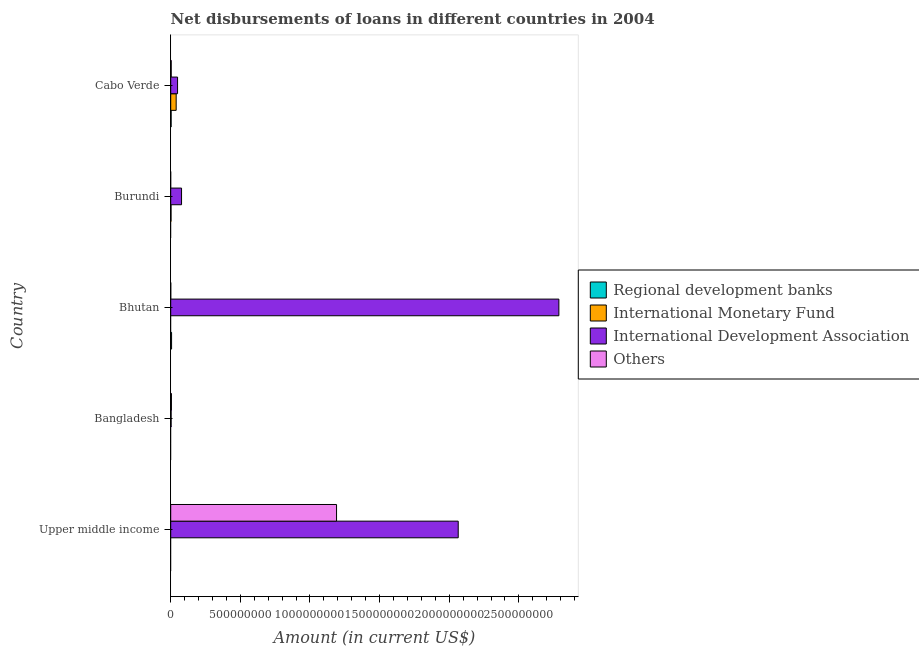How many different coloured bars are there?
Give a very brief answer. 4. Are the number of bars per tick equal to the number of legend labels?
Offer a terse response. No. Are the number of bars on each tick of the Y-axis equal?
Make the answer very short. No. What is the label of the 1st group of bars from the top?
Your response must be concise. Cabo Verde. In how many cases, is the number of bars for a given country not equal to the number of legend labels?
Your answer should be compact. 4. What is the amount of loan disimbursed by international development association in Burundi?
Make the answer very short. 7.78e+07. Across all countries, what is the maximum amount of loan disimbursed by international development association?
Make the answer very short. 2.79e+09. In which country was the amount of loan disimbursed by international development association maximum?
Your answer should be compact. Bhutan. What is the total amount of loan disimbursed by other organisations in the graph?
Your response must be concise. 1.20e+09. What is the difference between the amount of loan disimbursed by international development association in Bangladesh and that in Cabo Verde?
Offer a terse response. -4.62e+07. What is the difference between the amount of loan disimbursed by international development association in Bhutan and the amount of loan disimbursed by other organisations in Upper middle income?
Your response must be concise. 1.60e+09. What is the average amount of loan disimbursed by international monetary fund per country?
Offer a very short reply. 8.27e+06. What is the difference between the amount of loan disimbursed by regional development banks and amount of loan disimbursed by international development association in Cabo Verde?
Provide a short and direct response. -4.62e+07. In how many countries, is the amount of loan disimbursed by regional development banks greater than 1400000000 US$?
Offer a terse response. 0. What is the ratio of the amount of loan disimbursed by other organisations in Bhutan to that in Cabo Verde?
Provide a short and direct response. 0.02. What is the difference between the highest and the second highest amount of loan disimbursed by international development association?
Keep it short and to the point. 7.23e+08. What is the difference between the highest and the lowest amount of loan disimbursed by international development association?
Make the answer very short. 2.78e+09. Is the sum of the amount of loan disimbursed by international development association in Bangladesh and Cabo Verde greater than the maximum amount of loan disimbursed by regional development banks across all countries?
Make the answer very short. Yes. Is it the case that in every country, the sum of the amount of loan disimbursed by other organisations and amount of loan disimbursed by international development association is greater than the sum of amount of loan disimbursed by international monetary fund and amount of loan disimbursed by regional development banks?
Offer a terse response. No. Is it the case that in every country, the sum of the amount of loan disimbursed by regional development banks and amount of loan disimbursed by international monetary fund is greater than the amount of loan disimbursed by international development association?
Provide a short and direct response. No. How many bars are there?
Keep it short and to the point. 13. Does the graph contain any zero values?
Keep it short and to the point. Yes. Does the graph contain grids?
Offer a terse response. No. How many legend labels are there?
Your answer should be very brief. 4. How are the legend labels stacked?
Give a very brief answer. Vertical. What is the title of the graph?
Your answer should be compact. Net disbursements of loans in different countries in 2004. Does "Payroll services" appear as one of the legend labels in the graph?
Your response must be concise. No. What is the Amount (in current US$) in International Development Association in Upper middle income?
Offer a terse response. 2.06e+09. What is the Amount (in current US$) of Others in Upper middle income?
Provide a succinct answer. 1.19e+09. What is the Amount (in current US$) of Regional development banks in Bangladesh?
Ensure brevity in your answer.  0. What is the Amount (in current US$) in International Development Association in Bangladesh?
Ensure brevity in your answer.  2.97e+06. What is the Amount (in current US$) of Others in Bangladesh?
Give a very brief answer. 5.12e+06. What is the Amount (in current US$) in Regional development banks in Bhutan?
Your answer should be compact. 6.13e+06. What is the Amount (in current US$) of International Monetary Fund in Bhutan?
Your answer should be very brief. 0. What is the Amount (in current US$) in International Development Association in Bhutan?
Your answer should be very brief. 2.79e+09. What is the Amount (in current US$) of Others in Bhutan?
Offer a terse response. 6.50e+04. What is the Amount (in current US$) of International Monetary Fund in Burundi?
Your answer should be compact. 2.24e+06. What is the Amount (in current US$) in International Development Association in Burundi?
Provide a short and direct response. 7.78e+07. What is the Amount (in current US$) in Others in Burundi?
Your answer should be compact. 0. What is the Amount (in current US$) in Regional development banks in Cabo Verde?
Offer a very short reply. 2.97e+06. What is the Amount (in current US$) of International Monetary Fund in Cabo Verde?
Give a very brief answer. 3.91e+07. What is the Amount (in current US$) in International Development Association in Cabo Verde?
Your answer should be compact. 4.92e+07. What is the Amount (in current US$) of Others in Cabo Verde?
Your response must be concise. 3.55e+06. Across all countries, what is the maximum Amount (in current US$) in Regional development banks?
Your response must be concise. 6.13e+06. Across all countries, what is the maximum Amount (in current US$) of International Monetary Fund?
Offer a terse response. 3.91e+07. Across all countries, what is the maximum Amount (in current US$) of International Development Association?
Keep it short and to the point. 2.79e+09. Across all countries, what is the maximum Amount (in current US$) of Others?
Give a very brief answer. 1.19e+09. Across all countries, what is the minimum Amount (in current US$) of Regional development banks?
Provide a succinct answer. 0. Across all countries, what is the minimum Amount (in current US$) of International Development Association?
Provide a short and direct response. 2.97e+06. What is the total Amount (in current US$) of Regional development banks in the graph?
Your response must be concise. 9.10e+06. What is the total Amount (in current US$) of International Monetary Fund in the graph?
Ensure brevity in your answer.  4.14e+07. What is the total Amount (in current US$) in International Development Association in the graph?
Provide a short and direct response. 4.98e+09. What is the total Amount (in current US$) in Others in the graph?
Offer a very short reply. 1.20e+09. What is the difference between the Amount (in current US$) in International Development Association in Upper middle income and that in Bangladesh?
Give a very brief answer. 2.06e+09. What is the difference between the Amount (in current US$) in Others in Upper middle income and that in Bangladesh?
Offer a terse response. 1.19e+09. What is the difference between the Amount (in current US$) of International Development Association in Upper middle income and that in Bhutan?
Your answer should be very brief. -7.23e+08. What is the difference between the Amount (in current US$) of Others in Upper middle income and that in Bhutan?
Make the answer very short. 1.19e+09. What is the difference between the Amount (in current US$) in International Development Association in Upper middle income and that in Burundi?
Offer a very short reply. 1.99e+09. What is the difference between the Amount (in current US$) of International Development Association in Upper middle income and that in Cabo Verde?
Offer a terse response. 2.02e+09. What is the difference between the Amount (in current US$) in Others in Upper middle income and that in Cabo Verde?
Your answer should be very brief. 1.19e+09. What is the difference between the Amount (in current US$) of International Development Association in Bangladesh and that in Bhutan?
Provide a short and direct response. -2.78e+09. What is the difference between the Amount (in current US$) of Others in Bangladesh and that in Bhutan?
Offer a terse response. 5.05e+06. What is the difference between the Amount (in current US$) of International Development Association in Bangladesh and that in Burundi?
Offer a terse response. -7.48e+07. What is the difference between the Amount (in current US$) of International Development Association in Bangladesh and that in Cabo Verde?
Your response must be concise. -4.62e+07. What is the difference between the Amount (in current US$) of Others in Bangladesh and that in Cabo Verde?
Ensure brevity in your answer.  1.57e+06. What is the difference between the Amount (in current US$) of International Development Association in Bhutan and that in Burundi?
Your answer should be very brief. 2.71e+09. What is the difference between the Amount (in current US$) in Regional development banks in Bhutan and that in Cabo Verde?
Provide a short and direct response. 3.16e+06. What is the difference between the Amount (in current US$) of International Development Association in Bhutan and that in Cabo Verde?
Provide a short and direct response. 2.74e+09. What is the difference between the Amount (in current US$) in Others in Bhutan and that in Cabo Verde?
Make the answer very short. -3.48e+06. What is the difference between the Amount (in current US$) of International Monetary Fund in Burundi and that in Cabo Verde?
Ensure brevity in your answer.  -3.69e+07. What is the difference between the Amount (in current US$) in International Development Association in Burundi and that in Cabo Verde?
Offer a terse response. 2.86e+07. What is the difference between the Amount (in current US$) in International Development Association in Upper middle income and the Amount (in current US$) in Others in Bangladesh?
Your answer should be very brief. 2.06e+09. What is the difference between the Amount (in current US$) of International Development Association in Upper middle income and the Amount (in current US$) of Others in Bhutan?
Make the answer very short. 2.06e+09. What is the difference between the Amount (in current US$) in International Development Association in Upper middle income and the Amount (in current US$) in Others in Cabo Verde?
Offer a terse response. 2.06e+09. What is the difference between the Amount (in current US$) in International Development Association in Bangladesh and the Amount (in current US$) in Others in Bhutan?
Your response must be concise. 2.90e+06. What is the difference between the Amount (in current US$) in International Development Association in Bangladesh and the Amount (in current US$) in Others in Cabo Verde?
Offer a very short reply. -5.82e+05. What is the difference between the Amount (in current US$) in Regional development banks in Bhutan and the Amount (in current US$) in International Monetary Fund in Burundi?
Give a very brief answer. 3.89e+06. What is the difference between the Amount (in current US$) of Regional development banks in Bhutan and the Amount (in current US$) of International Development Association in Burundi?
Ensure brevity in your answer.  -7.16e+07. What is the difference between the Amount (in current US$) of Regional development banks in Bhutan and the Amount (in current US$) of International Monetary Fund in Cabo Verde?
Ensure brevity in your answer.  -3.30e+07. What is the difference between the Amount (in current US$) in Regional development banks in Bhutan and the Amount (in current US$) in International Development Association in Cabo Verde?
Provide a short and direct response. -4.30e+07. What is the difference between the Amount (in current US$) in Regional development banks in Bhutan and the Amount (in current US$) in Others in Cabo Verde?
Offer a very short reply. 2.58e+06. What is the difference between the Amount (in current US$) of International Development Association in Bhutan and the Amount (in current US$) of Others in Cabo Verde?
Your answer should be very brief. 2.78e+09. What is the difference between the Amount (in current US$) in International Monetary Fund in Burundi and the Amount (in current US$) in International Development Association in Cabo Verde?
Make the answer very short. -4.69e+07. What is the difference between the Amount (in current US$) in International Monetary Fund in Burundi and the Amount (in current US$) in Others in Cabo Verde?
Give a very brief answer. -1.31e+06. What is the difference between the Amount (in current US$) in International Development Association in Burundi and the Amount (in current US$) in Others in Cabo Verde?
Provide a short and direct response. 7.42e+07. What is the average Amount (in current US$) in Regional development banks per country?
Your answer should be very brief. 1.82e+06. What is the average Amount (in current US$) of International Monetary Fund per country?
Offer a very short reply. 8.27e+06. What is the average Amount (in current US$) in International Development Association per country?
Give a very brief answer. 9.96e+08. What is the average Amount (in current US$) of Others per country?
Ensure brevity in your answer.  2.40e+08. What is the difference between the Amount (in current US$) of International Development Association and Amount (in current US$) of Others in Upper middle income?
Your answer should be compact. 8.74e+08. What is the difference between the Amount (in current US$) of International Development Association and Amount (in current US$) of Others in Bangladesh?
Keep it short and to the point. -2.15e+06. What is the difference between the Amount (in current US$) of Regional development banks and Amount (in current US$) of International Development Association in Bhutan?
Provide a short and direct response. -2.78e+09. What is the difference between the Amount (in current US$) in Regional development banks and Amount (in current US$) in Others in Bhutan?
Give a very brief answer. 6.07e+06. What is the difference between the Amount (in current US$) of International Development Association and Amount (in current US$) of Others in Bhutan?
Give a very brief answer. 2.79e+09. What is the difference between the Amount (in current US$) in International Monetary Fund and Amount (in current US$) in International Development Association in Burundi?
Your answer should be very brief. -7.55e+07. What is the difference between the Amount (in current US$) in Regional development banks and Amount (in current US$) in International Monetary Fund in Cabo Verde?
Your response must be concise. -3.62e+07. What is the difference between the Amount (in current US$) in Regional development banks and Amount (in current US$) in International Development Association in Cabo Verde?
Make the answer very short. -4.62e+07. What is the difference between the Amount (in current US$) of Regional development banks and Amount (in current US$) of Others in Cabo Verde?
Your answer should be compact. -5.80e+05. What is the difference between the Amount (in current US$) of International Monetary Fund and Amount (in current US$) of International Development Association in Cabo Verde?
Give a very brief answer. -1.00e+07. What is the difference between the Amount (in current US$) in International Monetary Fund and Amount (in current US$) in Others in Cabo Verde?
Make the answer very short. 3.56e+07. What is the difference between the Amount (in current US$) in International Development Association and Amount (in current US$) in Others in Cabo Verde?
Your answer should be very brief. 4.56e+07. What is the ratio of the Amount (in current US$) of International Development Association in Upper middle income to that in Bangladesh?
Keep it short and to the point. 696.08. What is the ratio of the Amount (in current US$) in Others in Upper middle income to that in Bangladesh?
Offer a terse response. 232.76. What is the ratio of the Amount (in current US$) in International Development Association in Upper middle income to that in Bhutan?
Offer a terse response. 0.74. What is the ratio of the Amount (in current US$) of Others in Upper middle income to that in Bhutan?
Your answer should be very brief. 1.83e+04. What is the ratio of the Amount (in current US$) in International Development Association in Upper middle income to that in Burundi?
Make the answer very short. 26.55. What is the ratio of the Amount (in current US$) of International Development Association in Upper middle income to that in Cabo Verde?
Offer a terse response. 41.99. What is the ratio of the Amount (in current US$) of Others in Upper middle income to that in Cabo Verde?
Provide a succinct answer. 335.63. What is the ratio of the Amount (in current US$) of International Development Association in Bangladesh to that in Bhutan?
Keep it short and to the point. 0. What is the ratio of the Amount (in current US$) in Others in Bangladesh to that in Bhutan?
Your response must be concise. 78.71. What is the ratio of the Amount (in current US$) of International Development Association in Bangladesh to that in Burundi?
Make the answer very short. 0.04. What is the ratio of the Amount (in current US$) of International Development Association in Bangladesh to that in Cabo Verde?
Ensure brevity in your answer.  0.06. What is the ratio of the Amount (in current US$) in Others in Bangladesh to that in Cabo Verde?
Provide a succinct answer. 1.44. What is the ratio of the Amount (in current US$) in International Development Association in Bhutan to that in Burundi?
Your answer should be compact. 35.85. What is the ratio of the Amount (in current US$) in Regional development banks in Bhutan to that in Cabo Verde?
Offer a very short reply. 2.07. What is the ratio of the Amount (in current US$) in International Development Association in Bhutan to that in Cabo Verde?
Provide a short and direct response. 56.7. What is the ratio of the Amount (in current US$) in Others in Bhutan to that in Cabo Verde?
Keep it short and to the point. 0.02. What is the ratio of the Amount (in current US$) in International Monetary Fund in Burundi to that in Cabo Verde?
Your response must be concise. 0.06. What is the ratio of the Amount (in current US$) in International Development Association in Burundi to that in Cabo Verde?
Provide a short and direct response. 1.58. What is the difference between the highest and the second highest Amount (in current US$) of International Development Association?
Ensure brevity in your answer.  7.23e+08. What is the difference between the highest and the second highest Amount (in current US$) in Others?
Ensure brevity in your answer.  1.19e+09. What is the difference between the highest and the lowest Amount (in current US$) of Regional development banks?
Provide a short and direct response. 6.13e+06. What is the difference between the highest and the lowest Amount (in current US$) of International Monetary Fund?
Make the answer very short. 3.91e+07. What is the difference between the highest and the lowest Amount (in current US$) of International Development Association?
Your answer should be very brief. 2.78e+09. What is the difference between the highest and the lowest Amount (in current US$) of Others?
Keep it short and to the point. 1.19e+09. 